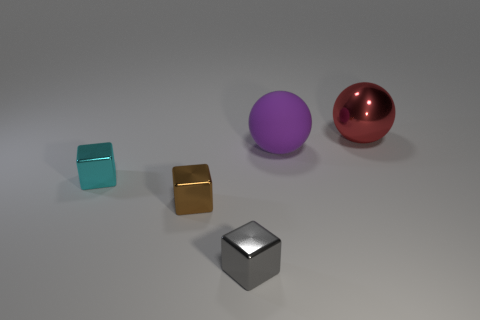How big is the object that is both to the right of the small brown thing and in front of the purple rubber ball?
Your answer should be compact. Small. What number of rubber things are either yellow blocks or big balls?
Make the answer very short. 1. Is the number of metallic objects that are to the left of the purple rubber object greater than the number of big green rubber spheres?
Provide a short and direct response. Yes. What is the sphere that is to the left of the large metallic sphere made of?
Provide a short and direct response. Rubber. How many things have the same material as the red sphere?
Provide a short and direct response. 3. There is a object that is both to the right of the brown cube and in front of the large matte ball; what is its shape?
Ensure brevity in your answer.  Cube. How many things are either things on the right side of the gray metal cube or brown blocks behind the small gray metallic cube?
Keep it short and to the point. 3. Are there an equal number of small gray blocks on the right side of the tiny gray metal cube and gray things in front of the purple rubber ball?
Provide a short and direct response. No. There is a large object in front of the metallic object that is right of the gray metallic block; what shape is it?
Offer a terse response. Sphere. Is there a brown object that has the same shape as the small cyan metallic object?
Offer a terse response. Yes. 